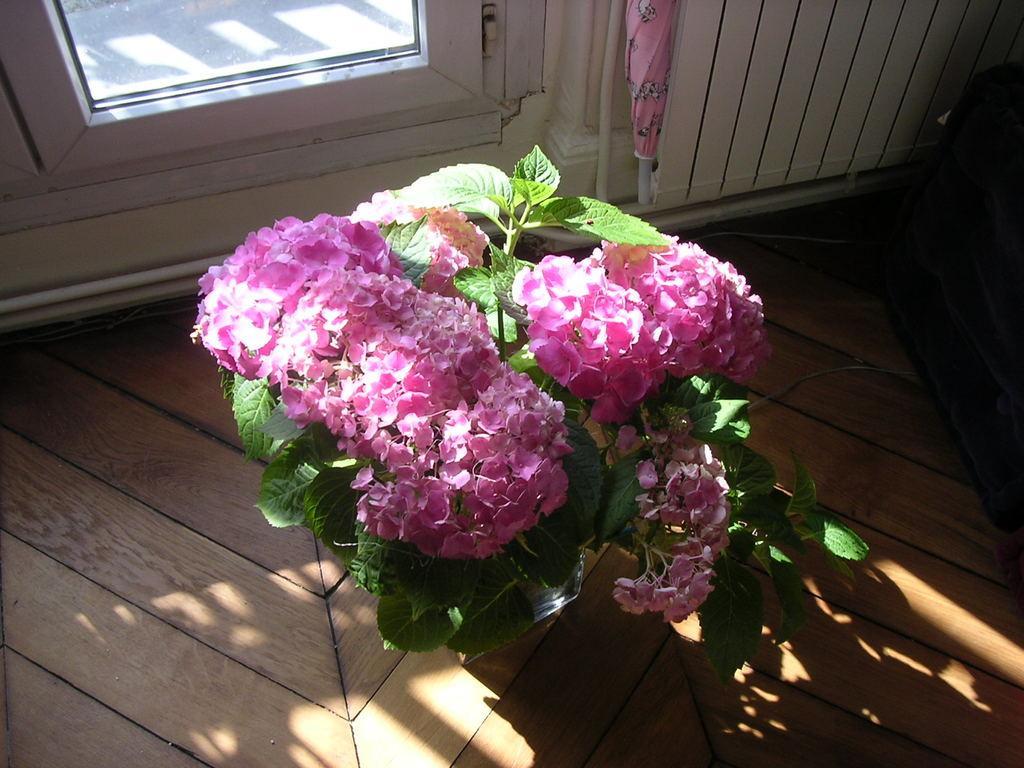Describe this image in one or two sentences. As we can see in the image there is a window, wall, an umbrella, plant and flowers. 